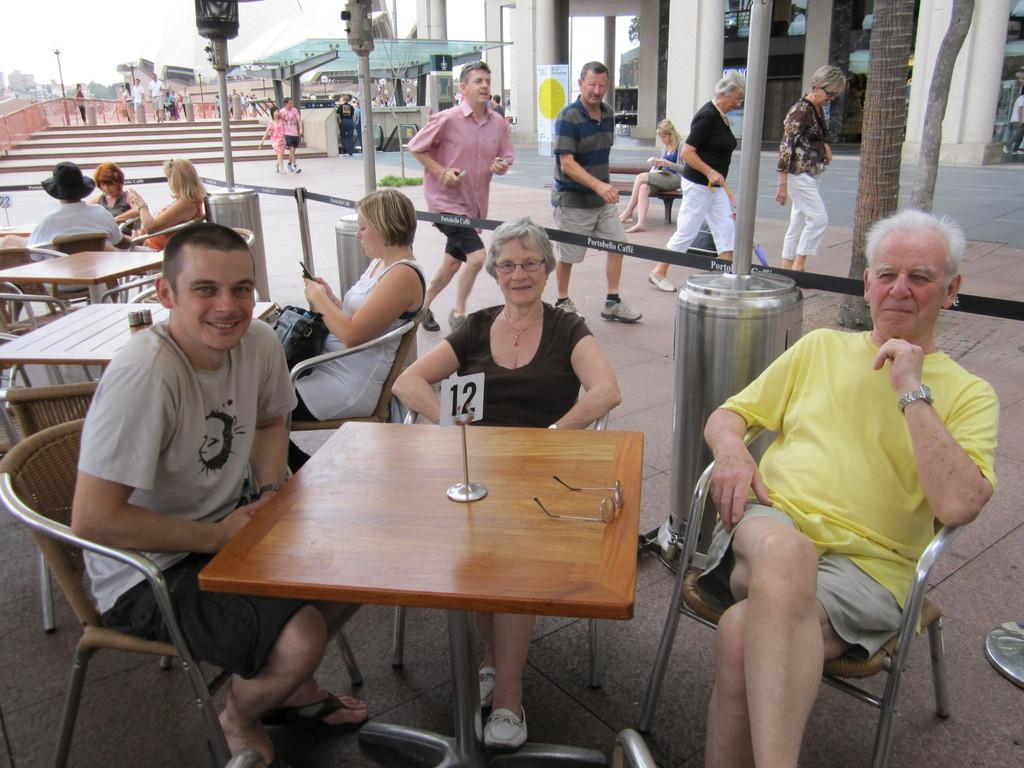How many people are in the image? There is a group of people in the image, but the exact number cannot be determined from the provided facts. What are some of the people in the image doing? Some people are seated on chairs, some are walking, and a man is running. What can be seen in the background of the image? There are stairs, a house, trees, and tables in the image. What is the price of the air in the image? There is no mention of air or any pricing information in the image. The image simply shows a group of people, some of whom are seated, walking, or running, along with various background elements. 